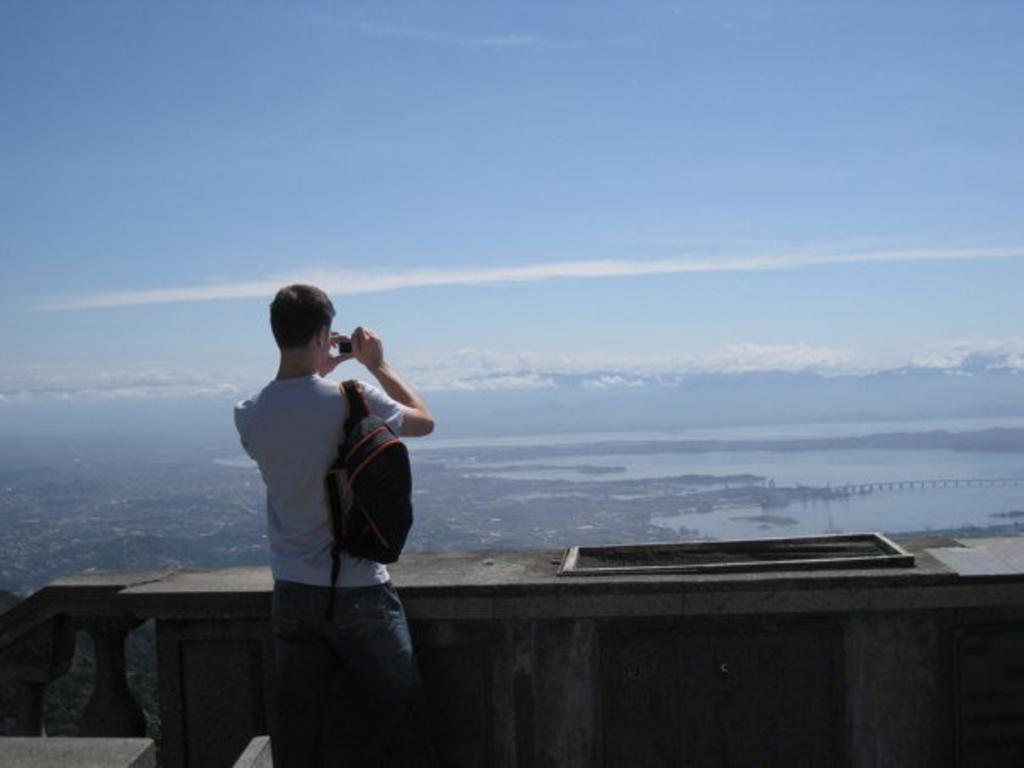What is the main subject of the image? There is a person standing at the wall in the center of the image. What can be seen in the background of the image? There is a bridge, trees, water, and the sky visible in the background of the image. What is the condition of the sky in the image? Clouds are present in the sky. How many spiders are crawling on the person's shoes in the image? There are no spiders or shoes present in the image. What type of donkey can be seen grazing near the bridge in the image? There is no donkey present in the image; the background features a bridge, trees, water, and the sky. 